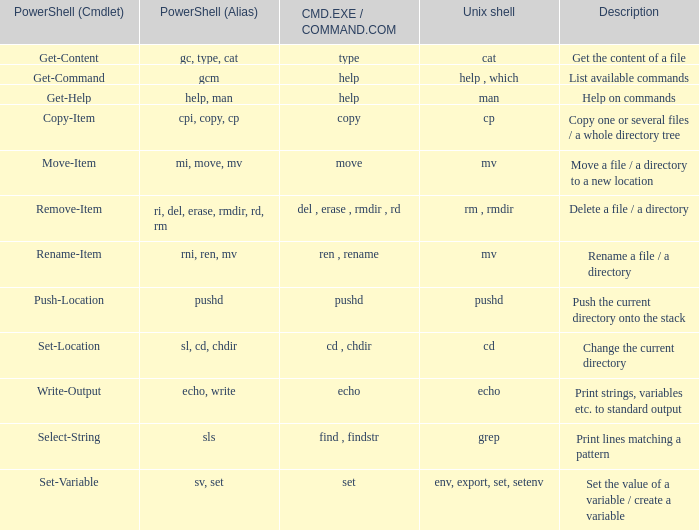What are the names of all unix shell with PowerShell (Cmdlet) of select-string? Grep. 